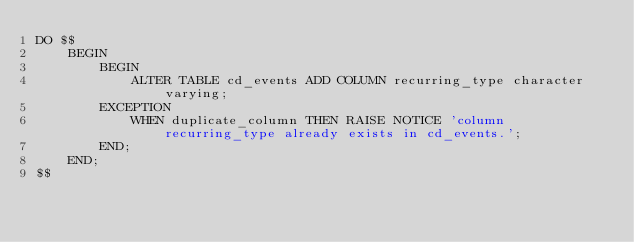<code> <loc_0><loc_0><loc_500><loc_500><_SQL_>DO $$
    BEGIN
        BEGIN
            ALTER TABLE cd_events ADD COLUMN recurring_type character varying;
        EXCEPTION
            WHEN duplicate_column THEN RAISE NOTICE 'column recurring_type already exists in cd_events.';
        END;
    END;
$$</code> 